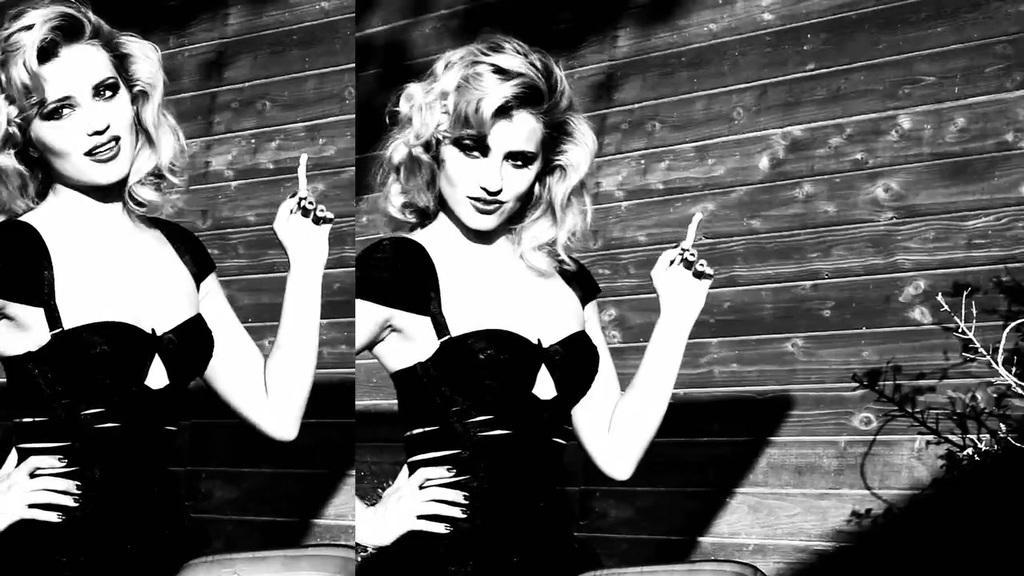Please provide a concise description of this image. Here we can see collage of two picture, in this pictures we can see a woman standing and holding something, on the right side of the image there is a plant, it is a black and white picture. 